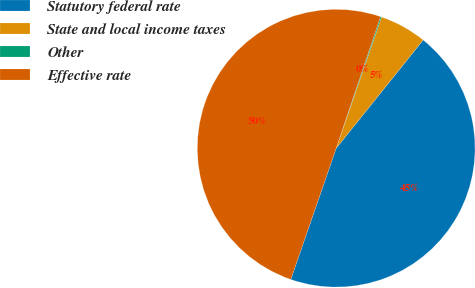<chart> <loc_0><loc_0><loc_500><loc_500><pie_chart><fcel>Statutory federal rate<fcel>State and local income taxes<fcel>Other<fcel>Effective rate<nl><fcel>44.53%<fcel>5.47%<fcel>0.13%<fcel>49.87%<nl></chart> 